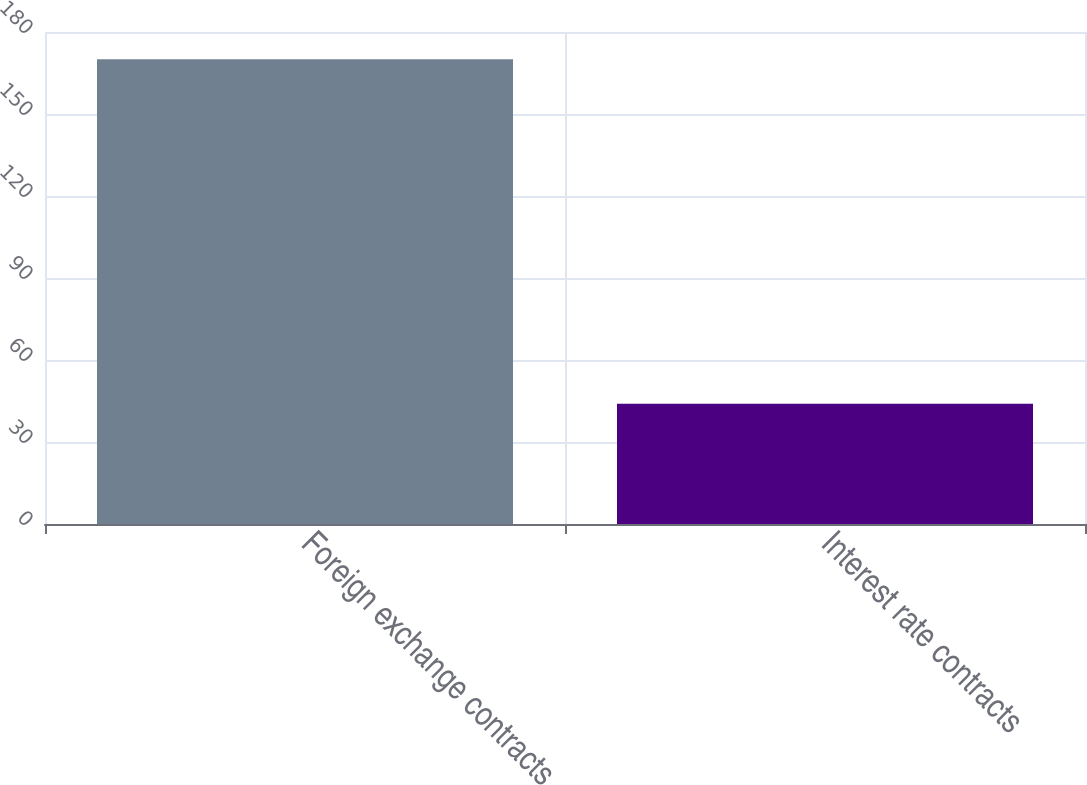Convert chart. <chart><loc_0><loc_0><loc_500><loc_500><bar_chart><fcel>Foreign exchange contracts<fcel>Interest rate contracts<nl><fcel>170<fcel>44<nl></chart> 